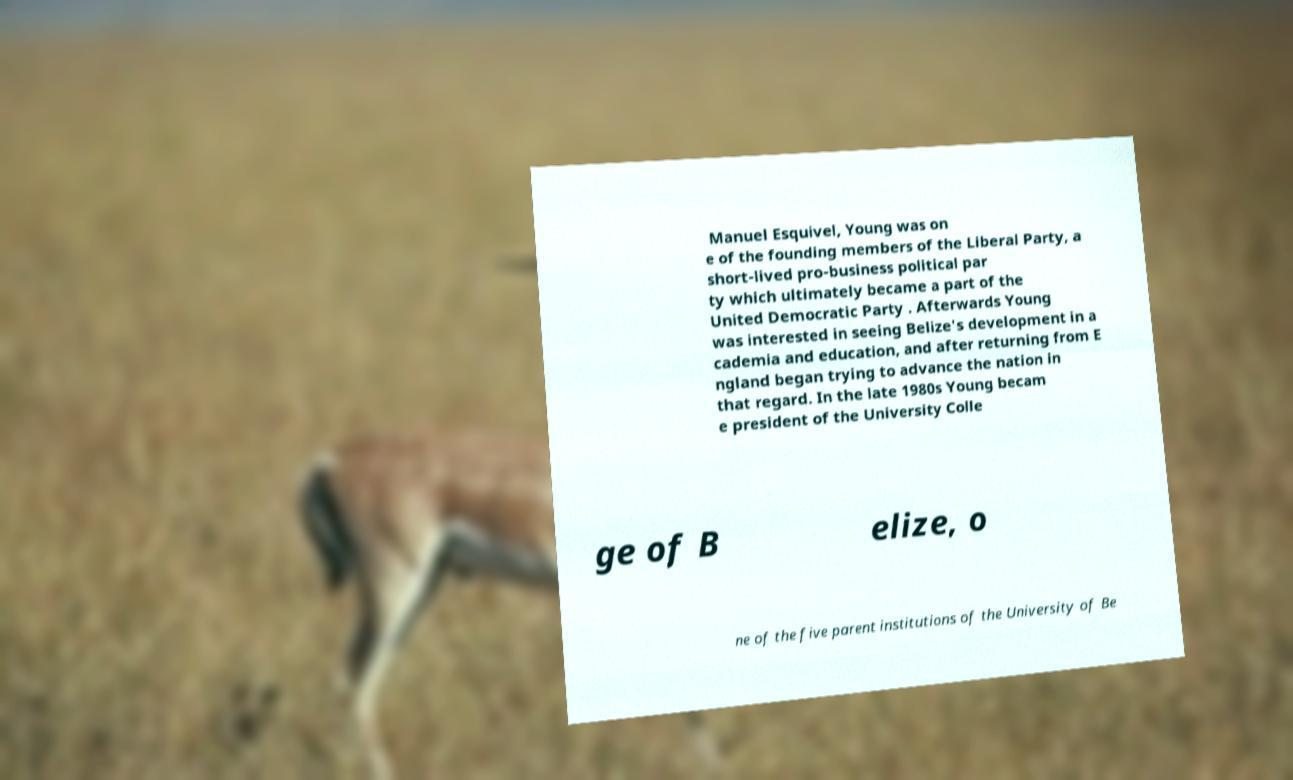Can you read and provide the text displayed in the image?This photo seems to have some interesting text. Can you extract and type it out for me? Manuel Esquivel, Young was on e of the founding members of the Liberal Party, a short-lived pro-business political par ty which ultimately became a part of the United Democratic Party . Afterwards Young was interested in seeing Belize's development in a cademia and education, and after returning from E ngland began trying to advance the nation in that regard. In the late 1980s Young becam e president of the University Colle ge of B elize, o ne of the five parent institutions of the University of Be 